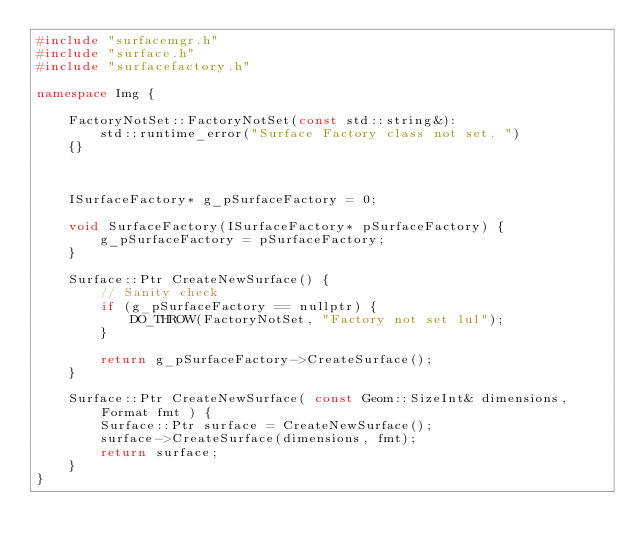Convert code to text. <code><loc_0><loc_0><loc_500><loc_500><_C++_>#include "surfacemgr.h"
#include "surface.h"
#include "surfacefactory.h"

namespace Img {

	FactoryNotSet::FactoryNotSet(const std::string&):
		std::runtime_error("Surface Factory class not set. ")
	{}



	ISurfaceFactory* g_pSurfaceFactory = 0;

	void SurfaceFactory(ISurfaceFactory* pSurfaceFactory) {
		g_pSurfaceFactory = pSurfaceFactory;
	}

	Surface::Ptr CreateNewSurface() {
		// Sanity check
		if (g_pSurfaceFactory == nullptr) {
			DO_THROW(FactoryNotSet, "Factory not set lul");
		}

		return g_pSurfaceFactory->CreateSurface();
	}

	Surface::Ptr CreateNewSurface( const Geom::SizeInt& dimensions, Format fmt ) {
		Surface::Ptr surface = CreateNewSurface();
		surface->CreateSurface(dimensions, fmt);
		return surface;
	}
}
</code> 